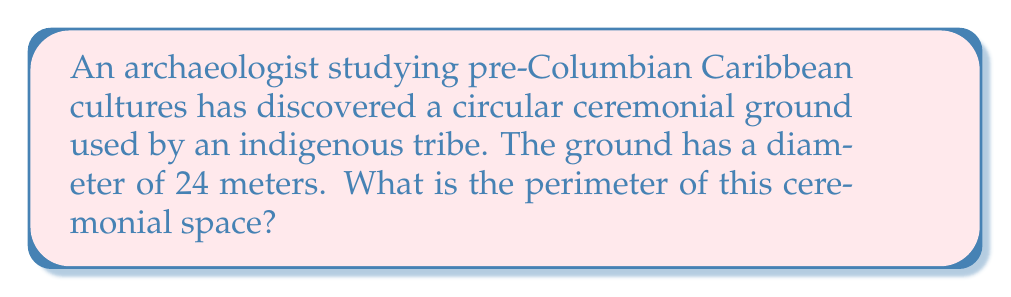Give your solution to this math problem. To find the perimeter of a circular area, we need to calculate its circumference. The formula for the circumference of a circle is:

$$C = \pi d$$

Where:
$C$ = circumference
$\pi$ = pi (approximately 3.14159)
$d$ = diameter

Given:
$d = 24$ meters

Let's substitute these values into the formula:

$$C = \pi \cdot 24$$

Using $\pi \approx 3.14159$:

$$C \approx 3.14159 \cdot 24$$
$$C \approx 75.39816$$

Rounding to two decimal places:

$$C \approx 75.40 \text{ meters}$$

[asy]
unitsize(4mm);
draw(circle((0,0),12));
draw((-12,0)--(12,0),dashed);
label("24 m", (0,-12.5), S);
[/asy]

Therefore, the perimeter of the circular ceremonial ground is approximately 75.40 meters.
Answer: $75.40 \text{ m}$ 